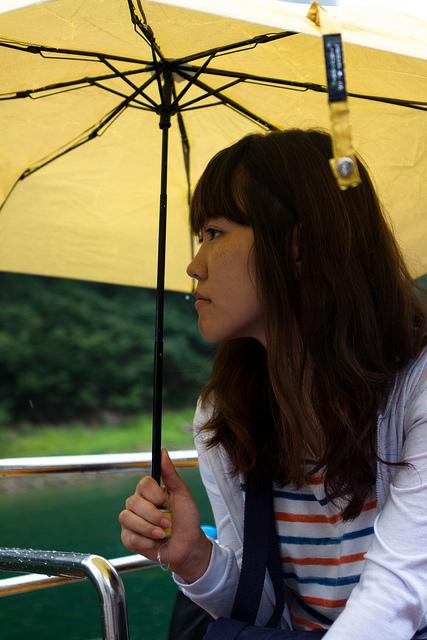When the rain stops how will this umbrella be stored?

Choices:
A) folded
B) outside
C) upside down
D) vacation rental folded 